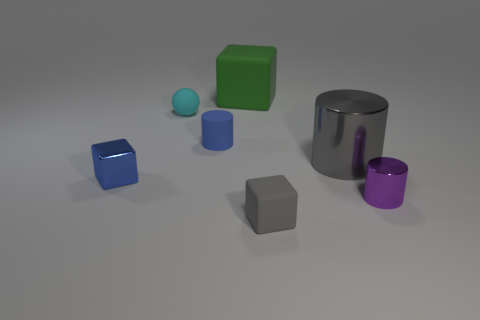Are there more large gray metal cylinders that are behind the tiny purple metallic thing than tiny gray spheres?
Provide a short and direct response. Yes. Are there any things?
Give a very brief answer. Yes. Is the large matte thing the same color as the small rubber block?
Ensure brevity in your answer.  No. What number of big things are either gray matte cubes or purple objects?
Offer a terse response. 0. Are there any other things that have the same color as the matte sphere?
Give a very brief answer. No. What shape is the small blue thing that is the same material as the tiny purple object?
Give a very brief answer. Cube. How big is the block that is to the right of the large rubber thing?
Provide a succinct answer. Small. The purple metal object has what shape?
Your answer should be very brief. Cylinder. Do the gray thing to the right of the gray matte cube and the rubber block that is behind the tiny purple cylinder have the same size?
Provide a short and direct response. Yes. What size is the matte object that is behind the cyan thing right of the small shiny object behind the tiny metal cylinder?
Give a very brief answer. Large. 